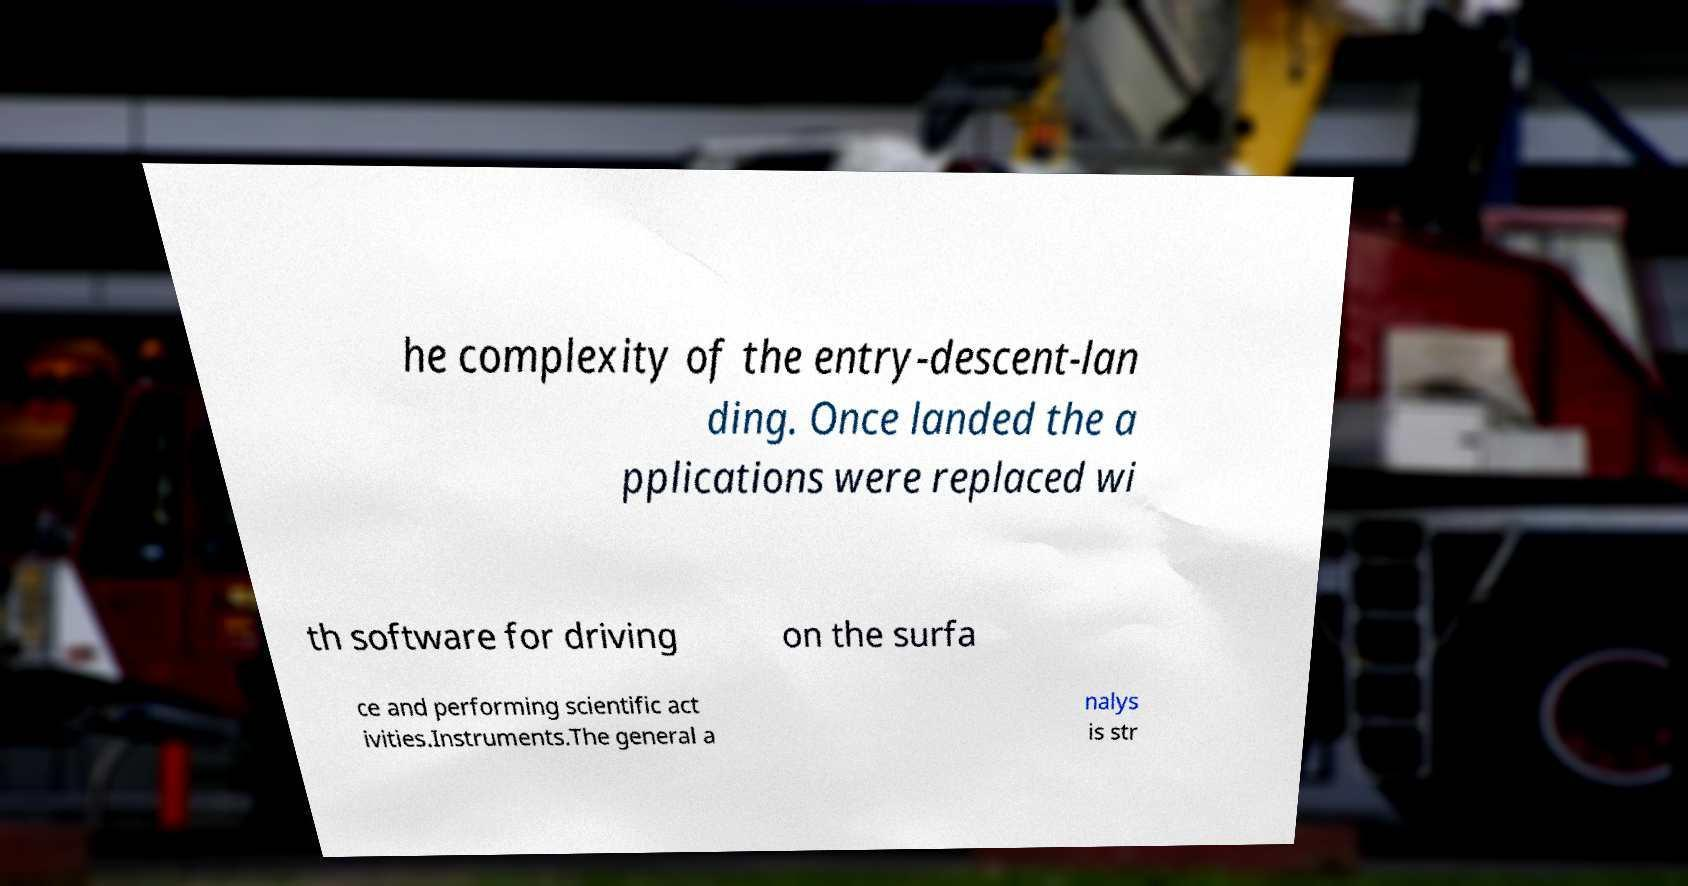Can you read and provide the text displayed in the image?This photo seems to have some interesting text. Can you extract and type it out for me? he complexity of the entry-descent-lan ding. Once landed the a pplications were replaced wi th software for driving on the surfa ce and performing scientific act ivities.Instruments.The general a nalys is str 